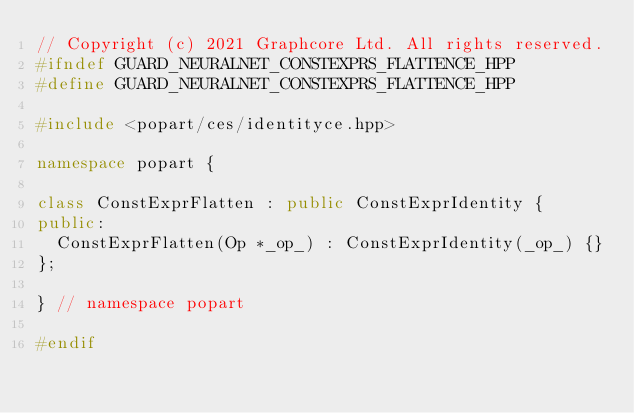Convert code to text. <code><loc_0><loc_0><loc_500><loc_500><_C++_>// Copyright (c) 2021 Graphcore Ltd. All rights reserved.
#ifndef GUARD_NEURALNET_CONSTEXPRS_FLATTENCE_HPP
#define GUARD_NEURALNET_CONSTEXPRS_FLATTENCE_HPP

#include <popart/ces/identityce.hpp>

namespace popart {

class ConstExprFlatten : public ConstExprIdentity {
public:
  ConstExprFlatten(Op *_op_) : ConstExprIdentity(_op_) {}
};

} // namespace popart

#endif
</code> 